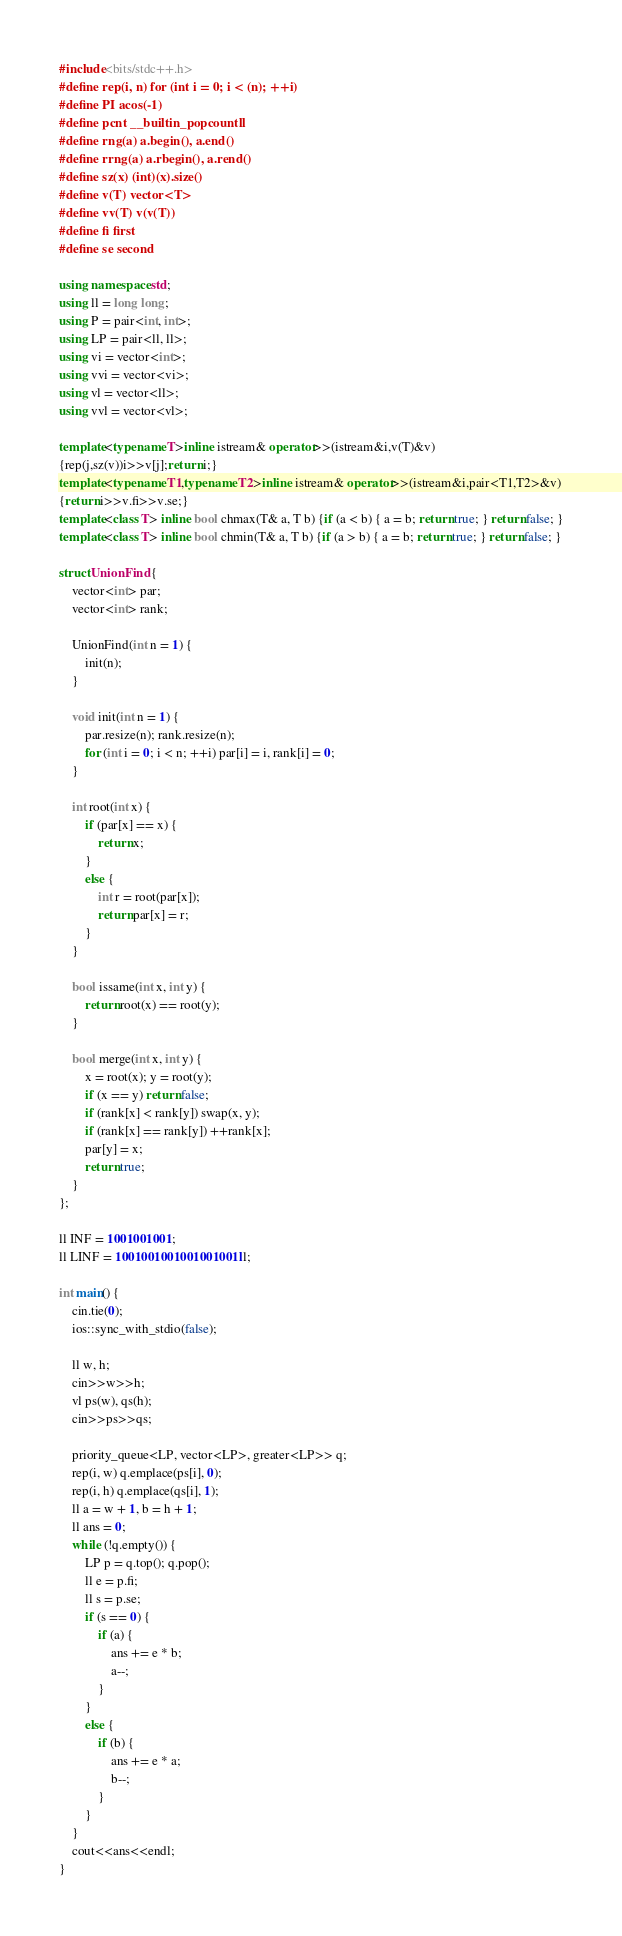Convert code to text. <code><loc_0><loc_0><loc_500><loc_500><_C++_>#include<bits/stdc++.h>
#define rep(i, n) for (int i = 0; i < (n); ++i) 
#define PI acos(-1)
#define pcnt __builtin_popcountll
#define rng(a) a.begin(), a.end()
#define rrng(a) a.rbegin(), a.rend()
#define sz(x) (int)(x).size()
#define v(T) vector<T>
#define vv(T) v(v(T))
#define fi first
#define se second

using namespace std;
using ll = long long;
using P = pair<int, int>;
using LP = pair<ll, ll>;
using vi = vector<int>;
using vvi = vector<vi>;
using vl = vector<ll>;
using vvl = vector<vl>;

template<typename T>inline istream& operator>>(istream&i,v(T)&v)
{rep(j,sz(v))i>>v[j];return i;}
template<typename T1,typename T2>inline istream& operator>>(istream&i,pair<T1,T2>&v)
{return i>>v.fi>>v.se;}
template<class T> inline bool chmax(T& a, T b) {if (a < b) { a = b; return true; } return false; }
template<class T> inline bool chmin(T& a, T b) {if (a > b) { a = b; return true; } return false; }

struct UnionFind {
    vector<int> par;
    vector<int> rank;
    
    UnionFind(int n = 1) {
        init(n);
    }
    
    void init(int n = 1) {
        par.resize(n); rank.resize(n);
        for (int i = 0; i < n; ++i) par[i] = i, rank[i] = 0;
    }
    
    int root(int x) {
        if (par[x] == x) {
            return x;
        }
        else {
            int r = root(par[x]);
            return par[x] = r;
        }
    }
    
    bool issame(int x, int y) {
        return root(x) == root(y);
    }
    
    bool merge(int x, int y) {
        x = root(x); y = root(y);
        if (x == y) return false;
        if (rank[x] < rank[y]) swap(x, y);
        if (rank[x] == rank[y]) ++rank[x];
        par[y] = x;
        return true;
    }
};

ll INF = 1001001001;
ll LINF = 1001001001001001001ll;

int main() {
    cin.tie(0);
    ios::sync_with_stdio(false);

    ll w, h;
    cin>>w>>h;
    vl ps(w), qs(h);
    cin>>ps>>qs;

    priority_queue<LP, vector<LP>, greater<LP>> q;
    rep(i, w) q.emplace(ps[i], 0);
    rep(i, h) q.emplace(qs[i], 1);
    ll a = w + 1, b = h + 1;
    ll ans = 0;
    while (!q.empty()) {
        LP p = q.top(); q.pop();
        ll e = p.fi;
        ll s = p.se;
        if (s == 0) {
            if (a) {
                ans += e * b;
                a--;
            }
        }
        else {
            if (b) {
                ans += e * a;
                b--;
            }
        }
    }
    cout<<ans<<endl;
}</code> 